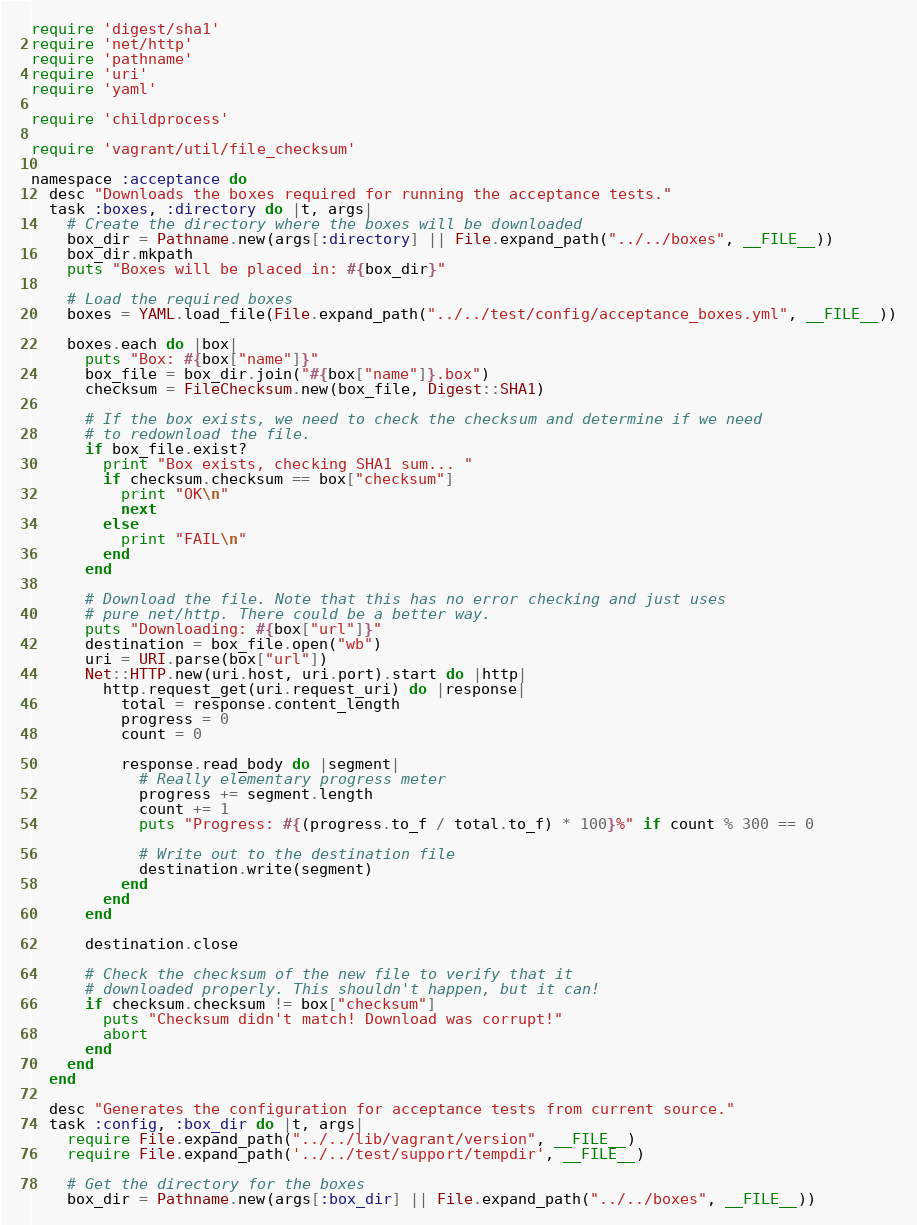Convert code to text. <code><loc_0><loc_0><loc_500><loc_500><_Ruby_>require 'digest/sha1'
require 'net/http'
require 'pathname'
require 'uri'
require 'yaml'

require 'childprocess'

require 'vagrant/util/file_checksum'

namespace :acceptance do
  desc "Downloads the boxes required for running the acceptance tests."
  task :boxes, :directory do |t, args|
    # Create the directory where the boxes will be downloaded
    box_dir = Pathname.new(args[:directory] || File.expand_path("../../boxes", __FILE__))
    box_dir.mkpath
    puts "Boxes will be placed in: #{box_dir}"

    # Load the required boxes
    boxes = YAML.load_file(File.expand_path("../../test/config/acceptance_boxes.yml", __FILE__))

    boxes.each do |box|
      puts "Box: #{box["name"]}"
      box_file = box_dir.join("#{box["name"]}.box")
      checksum = FileChecksum.new(box_file, Digest::SHA1)

      # If the box exists, we need to check the checksum and determine if we need
      # to redownload the file.
      if box_file.exist?
        print "Box exists, checking SHA1 sum... "
        if checksum.checksum == box["checksum"]
          print "OK\n"
          next
        else
          print "FAIL\n"
        end
      end

      # Download the file. Note that this has no error checking and just uses
      # pure net/http. There could be a better way.
      puts "Downloading: #{box["url"]}"
      destination = box_file.open("wb")
      uri = URI.parse(box["url"])
      Net::HTTP.new(uri.host, uri.port).start do |http|
        http.request_get(uri.request_uri) do |response|
          total = response.content_length
          progress = 0
          count = 0

          response.read_body do |segment|
            # Really elementary progress meter
            progress += segment.length
            count += 1
            puts "Progress: #{(progress.to_f / total.to_f) * 100}%" if count % 300 == 0

            # Write out to the destination file
            destination.write(segment)
          end
        end
      end

      destination.close

      # Check the checksum of the new file to verify that it
      # downloaded properly. This shouldn't happen, but it can!
      if checksum.checksum != box["checksum"]
        puts "Checksum didn't match! Download was corrupt!"
        abort
      end
    end
  end

  desc "Generates the configuration for acceptance tests from current source."
  task :config, :box_dir do |t, args|
    require File.expand_path("../../lib/vagrant/version", __FILE__)
    require File.expand_path('../../test/support/tempdir', __FILE__)

    # Get the directory for the boxes
    box_dir = Pathname.new(args[:box_dir] || File.expand_path("../../boxes", __FILE__))
</code> 